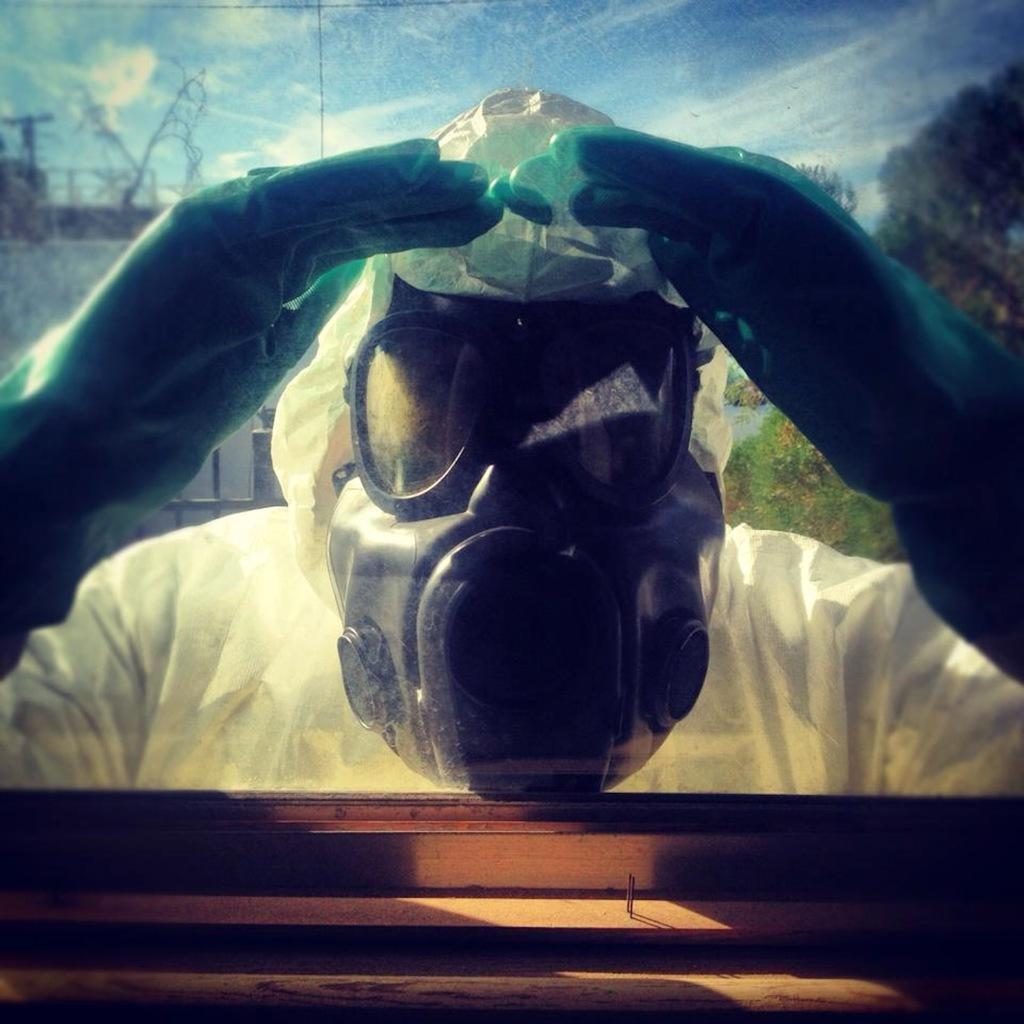Who is present in the image? There is a man in the image. What is the man wearing? The man is wearing a white dress. Can you describe the man's face? The man is wearing a mask on his face. What is the man doing in the image? The man is looking through a glass. What can be seen in the background of the image? There is a white color building and trees in the background of the image. Are there any women wearing skirts playing volleyball in the image? There are no women or volleyball players present in the image. 